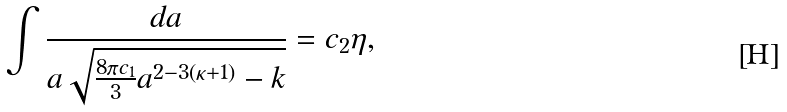Convert formula to latex. <formula><loc_0><loc_0><loc_500><loc_500>\int \frac { d a } { a \sqrt { \frac { 8 \pi c _ { 1 } } { 3 } a ^ { 2 - 3 ( \kappa + 1 ) } - k } } = c _ { 2 } \eta ,</formula> 